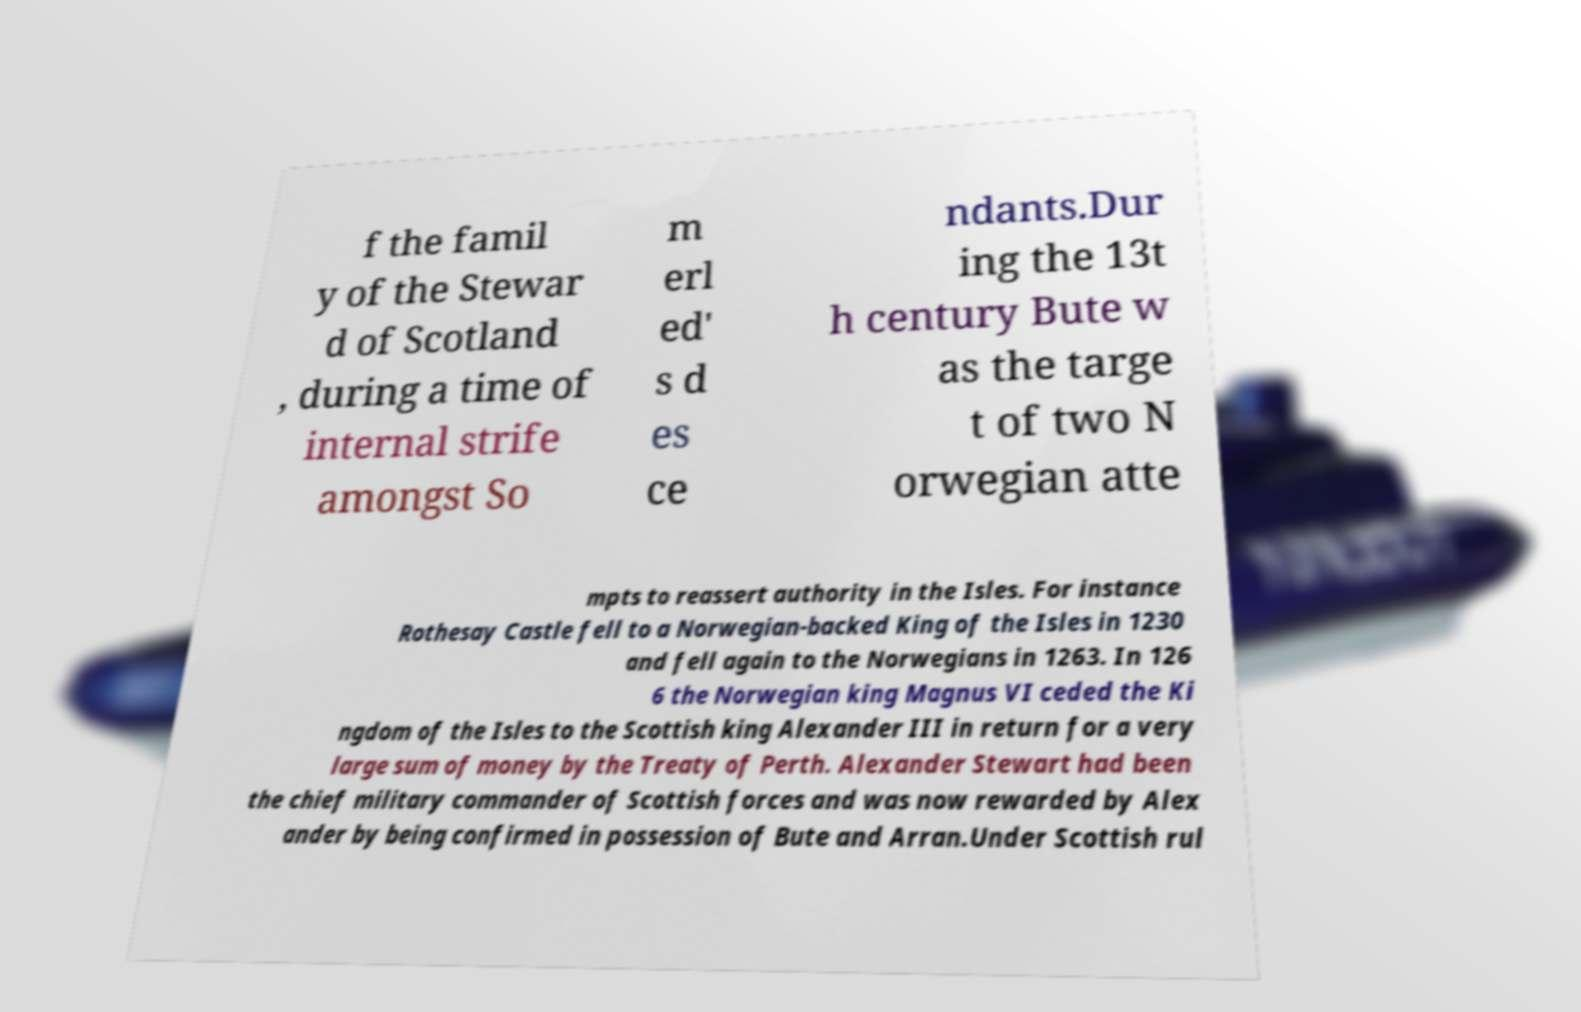I need the written content from this picture converted into text. Can you do that? f the famil y of the Stewar d of Scotland , during a time of internal strife amongst So m erl ed' s d es ce ndants.Dur ing the 13t h century Bute w as the targe t of two N orwegian atte mpts to reassert authority in the Isles. For instance Rothesay Castle fell to a Norwegian-backed King of the Isles in 1230 and fell again to the Norwegians in 1263. In 126 6 the Norwegian king Magnus VI ceded the Ki ngdom of the Isles to the Scottish king Alexander III in return for a very large sum of money by the Treaty of Perth. Alexander Stewart had been the chief military commander of Scottish forces and was now rewarded by Alex ander by being confirmed in possession of Bute and Arran.Under Scottish rul 